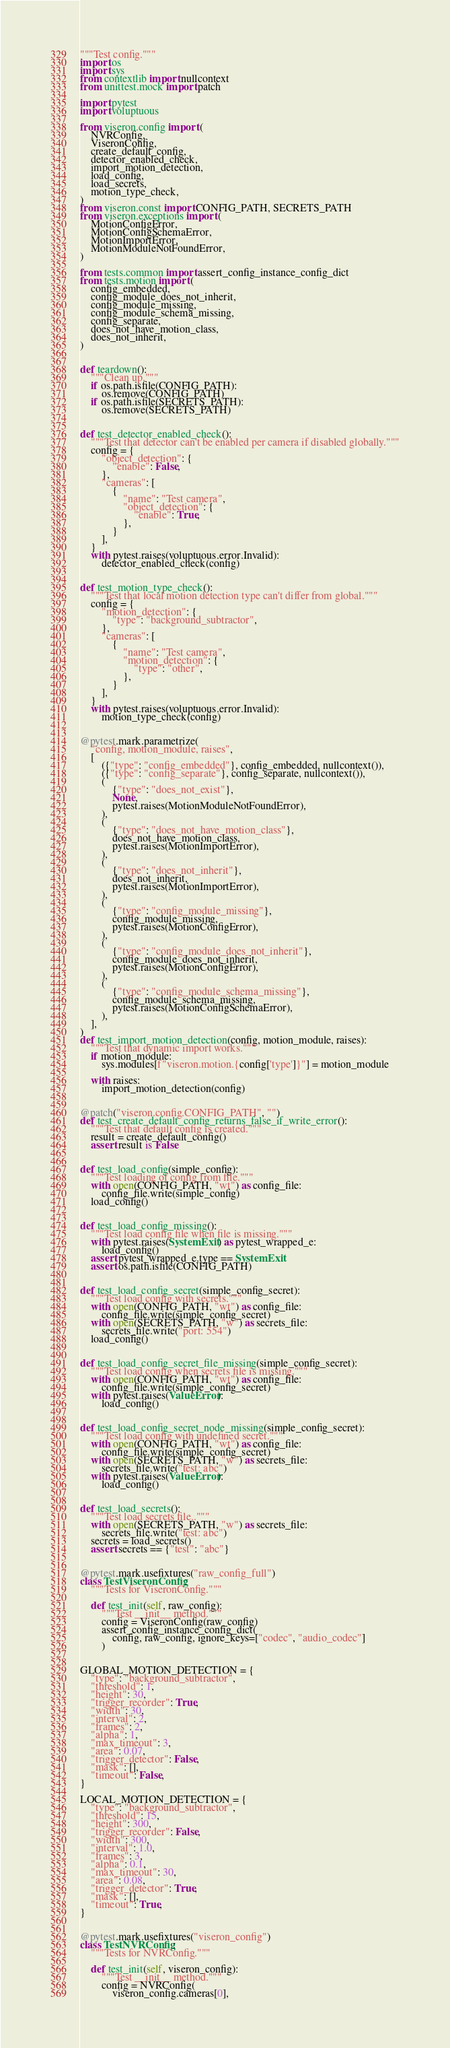Convert code to text. <code><loc_0><loc_0><loc_500><loc_500><_Python_>"""Test config."""
import os
import sys
from contextlib import nullcontext
from unittest.mock import patch

import pytest
import voluptuous

from viseron.config import (
    NVRConfig,
    ViseronConfig,
    create_default_config,
    detector_enabled_check,
    import_motion_detection,
    load_config,
    load_secrets,
    motion_type_check,
)
from viseron.const import CONFIG_PATH, SECRETS_PATH
from viseron.exceptions import (
    MotionConfigError,
    MotionConfigSchemaError,
    MotionImportError,
    MotionModuleNotFoundError,
)

from tests.common import assert_config_instance_config_dict
from tests.motion import (
    config_embedded,
    config_module_does_not_inherit,
    config_module_missing,
    config_module_schema_missing,
    config_separate,
    does_not_have_motion_class,
    does_not_inherit,
)


def teardown():
    """Clean up."""
    if os.path.isfile(CONFIG_PATH):
        os.remove(CONFIG_PATH)
    if os.path.isfile(SECRETS_PATH):
        os.remove(SECRETS_PATH)


def test_detector_enabled_check():
    """Test that detector can't be enabled per camera if disabled globally."""
    config = {
        "object_detection": {
            "enable": False,
        },
        "cameras": [
            {
                "name": "Test camera",
                "object_detection": {
                    "enable": True,
                },
            }
        ],
    }
    with pytest.raises(voluptuous.error.Invalid):
        detector_enabled_check(config)


def test_motion_type_check():
    """Test that local motion detection type can't differ from global."""
    config = {
        "motion_detection": {
            "type": "background_subtractor",
        },
        "cameras": [
            {
                "name": "Test camera",
                "motion_detection": {
                    "type": "other",
                },
            }
        ],
    }
    with pytest.raises(voluptuous.error.Invalid):
        motion_type_check(config)


@pytest.mark.parametrize(
    "config, motion_module, raises",
    [
        ({"type": "config_embedded"}, config_embedded, nullcontext()),
        ({"type": "config_separate"}, config_separate, nullcontext()),
        (
            {"type": "does_not_exist"},
            None,
            pytest.raises(MotionModuleNotFoundError),
        ),
        (
            {"type": "does_not_have_motion_class"},
            does_not_have_motion_class,
            pytest.raises(MotionImportError),
        ),
        (
            {"type": "does_not_inherit"},
            does_not_inherit,
            pytest.raises(MotionImportError),
        ),
        (
            {"type": "config_module_missing"},
            config_module_missing,
            pytest.raises(MotionConfigError),
        ),
        (
            {"type": "config_module_does_not_inherit"},
            config_module_does_not_inherit,
            pytest.raises(MotionConfigError),
        ),
        (
            {"type": "config_module_schema_missing"},
            config_module_schema_missing,
            pytest.raises(MotionConfigSchemaError),
        ),
    ],
)
def test_import_motion_detection(config, motion_module, raises):
    """Test that dynamic import works."""
    if motion_module:
        sys.modules[f"viseron.motion.{config['type']}"] = motion_module

    with raises:
        import_motion_detection(config)


@patch("viseron.config.CONFIG_PATH", "")
def test_create_default_config_returns_false_if_write_error():
    """Test that default config is created."""
    result = create_default_config()
    assert result is False


def test_load_config(simple_config):
    """Test loading of config from file."""
    with open(CONFIG_PATH, "wt") as config_file:
        config_file.write(simple_config)
    load_config()


def test_load_config_missing():
    """Test load config file when file is missing."""
    with pytest.raises(SystemExit) as pytest_wrapped_e:
        load_config()
    assert pytest_wrapped_e.type == SystemExit
    assert os.path.isfile(CONFIG_PATH)


def test_load_config_secret(simple_config_secret):
    """Test load config with secrets."""
    with open(CONFIG_PATH, "wt") as config_file:
        config_file.write(simple_config_secret)
    with open(SECRETS_PATH, "w") as secrets_file:
        secrets_file.write("port: 554")
    load_config()


def test_load_config_secret_file_missing(simple_config_secret):
    """Test load config when secrets file is missing."""
    with open(CONFIG_PATH, "wt") as config_file:
        config_file.write(simple_config_secret)
    with pytest.raises(ValueError):
        load_config()


def test_load_config_secret_node_missing(simple_config_secret):
    """Test load config with undefined secret."""
    with open(CONFIG_PATH, "wt") as config_file:
        config_file.write(simple_config_secret)
    with open(SECRETS_PATH, "w") as secrets_file:
        secrets_file.write("test: abc")
    with pytest.raises(ValueError):
        load_config()


def test_load_secrets():
    """Test load secrets file.."""
    with open(SECRETS_PATH, "w") as secrets_file:
        secrets_file.write("test: abc")
    secrets = load_secrets()
    assert secrets == {"test": "abc"}


@pytest.mark.usefixtures("raw_config_full")
class TestViseronConfig:
    """Tests for ViseronConfig."""

    def test_init(self, raw_config):
        """Test __init__ method."""
        config = ViseronConfig(raw_config)
        assert_config_instance_config_dict(
            config, raw_config, ignore_keys=["codec", "audio_codec"]
        )


GLOBAL_MOTION_DETECTION = {
    "type": "background_subtractor",
    "threshold": 1,
    "height": 30,
    "trigger_recorder": True,
    "width": 30,
    "interval": 2,
    "frames": 2,
    "alpha": 1,
    "max_timeout": 3,
    "area": 0.07,
    "trigger_detector": False,
    "mask": [],
    "timeout": False,
}

LOCAL_MOTION_DETECTION = {
    "type": "background_subtractor",
    "threshold": 15,
    "height": 300,
    "trigger_recorder": False,
    "width": 300,
    "interval": 1.0,
    "frames": 3,
    "alpha": 0.1,
    "max_timeout": 30,
    "area": 0.08,
    "trigger_detector": True,
    "mask": [],
    "timeout": True,
}


@pytest.mark.usefixtures("viseron_config")
class TestNVRConfig:
    """Tests for NVRConfig."""

    def test_init(self, viseron_config):
        """Test __init__ method."""
        config = NVRConfig(
            viseron_config.cameras[0],</code> 